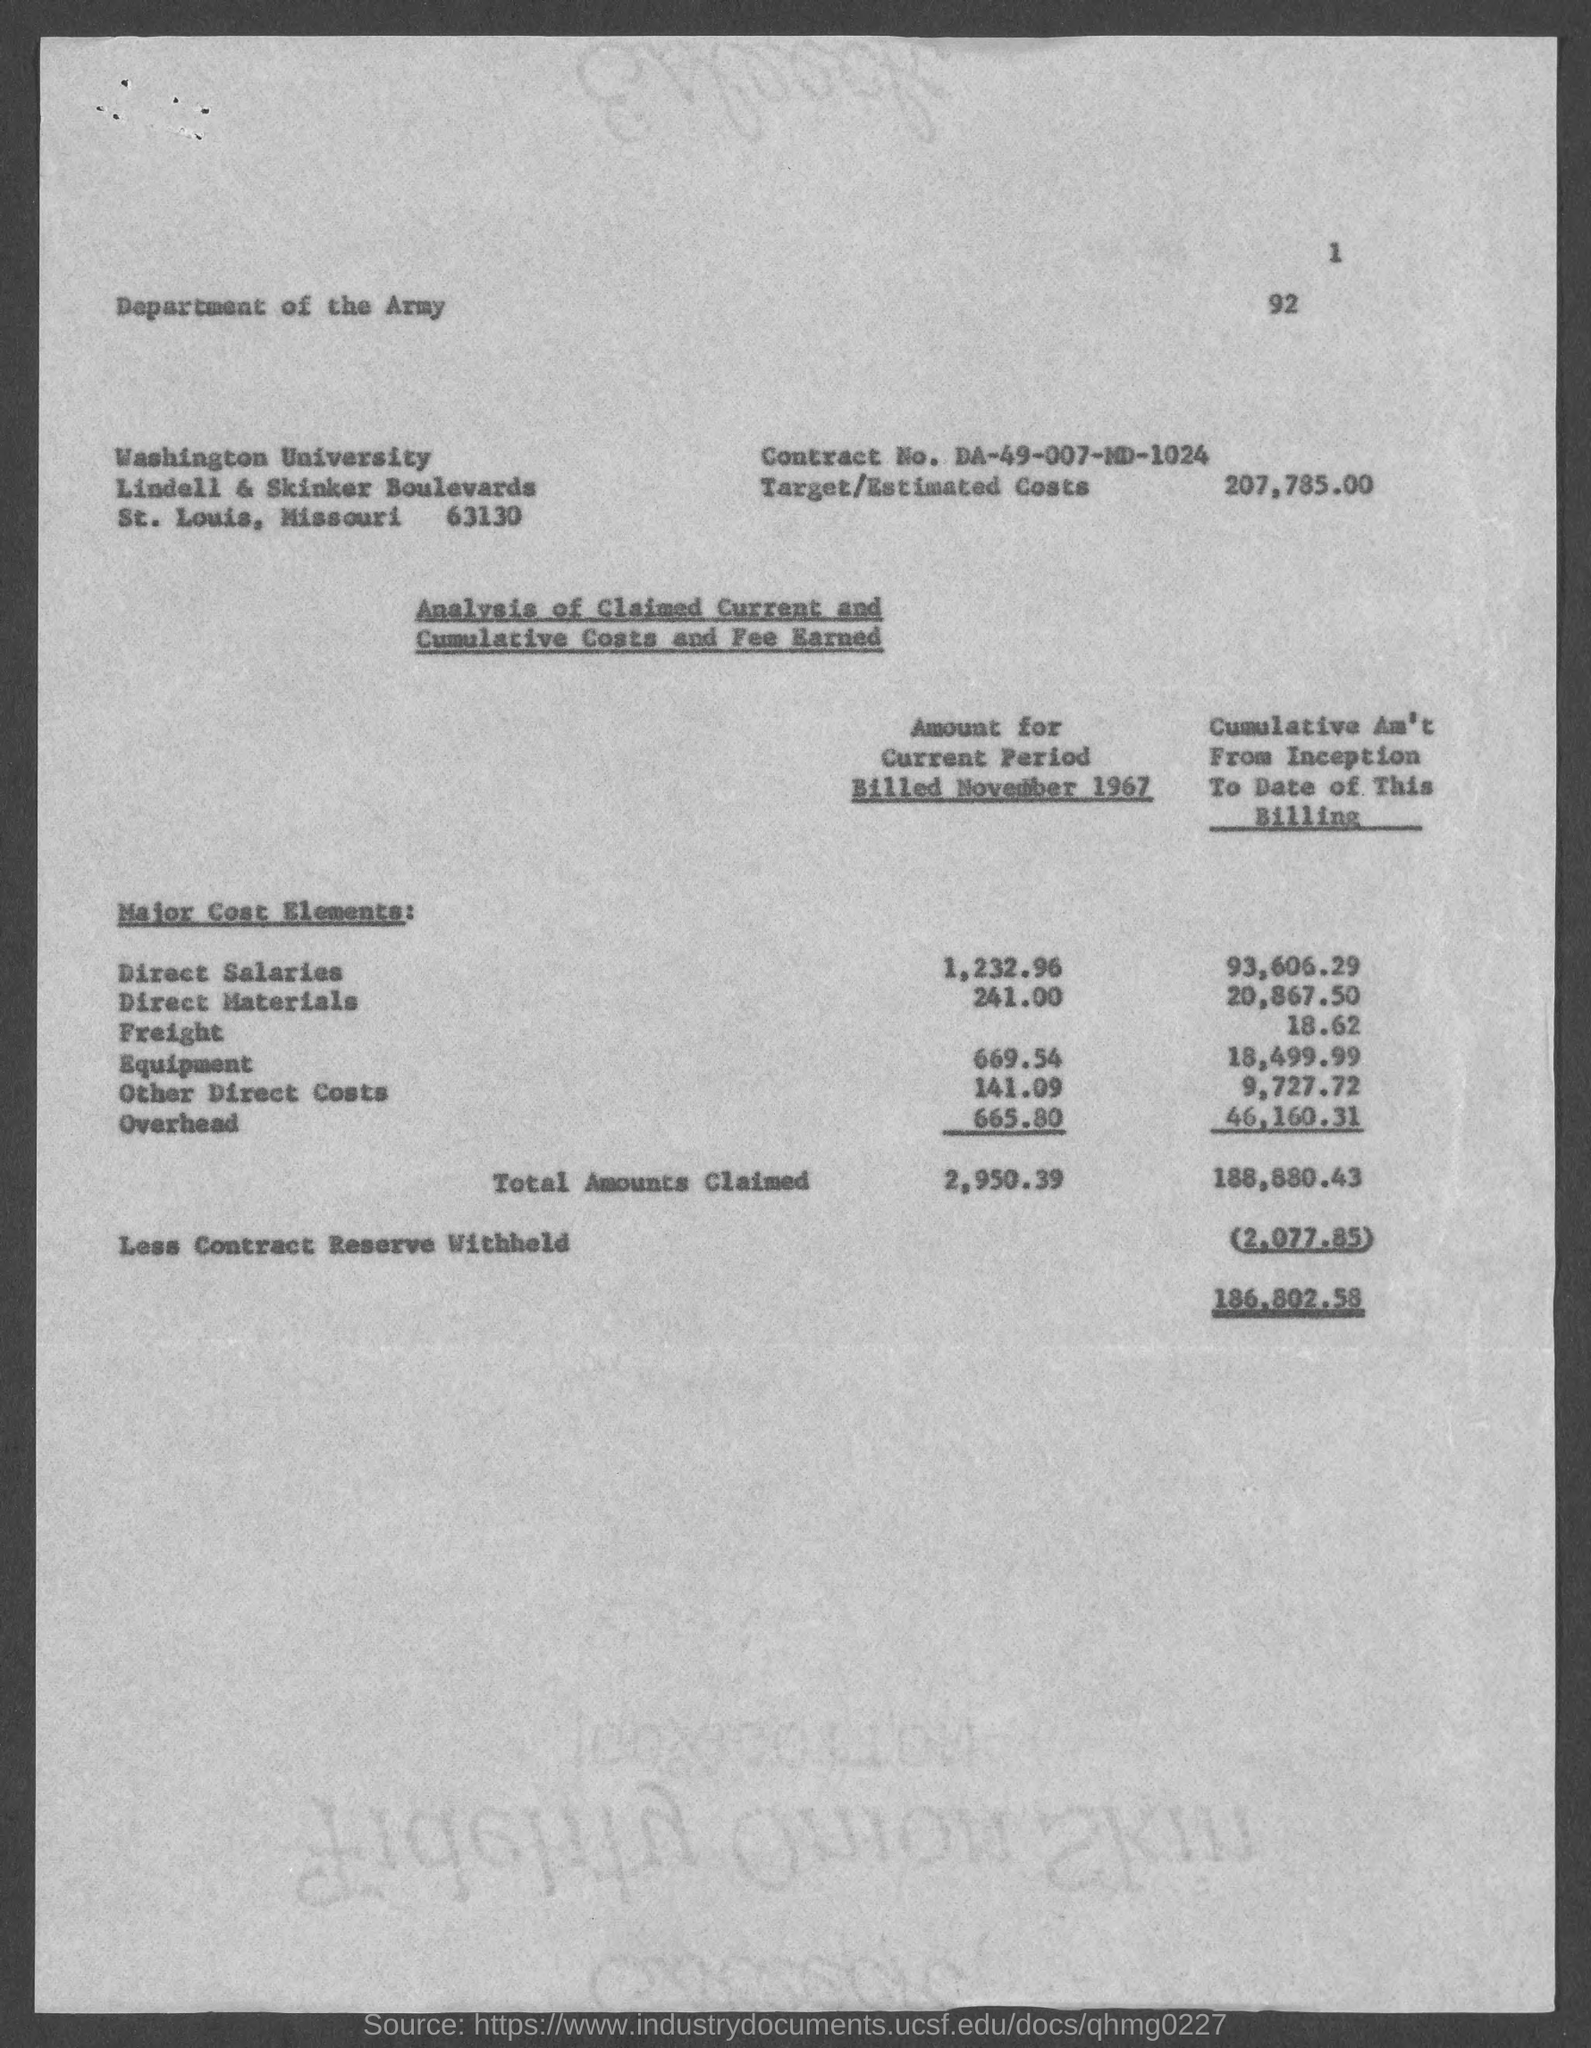Specify some key components in this picture. Washington University is located in the state of Missouri. The amount for the current period billed in November 1967 for Other Direct costs was $141.09. The amount of Direct Materials billed in November 1967 was $241.00. The less contract reserve withheld is 2,077.85. The amount for the current period billed in November 1967 for overhead was $665.80. 